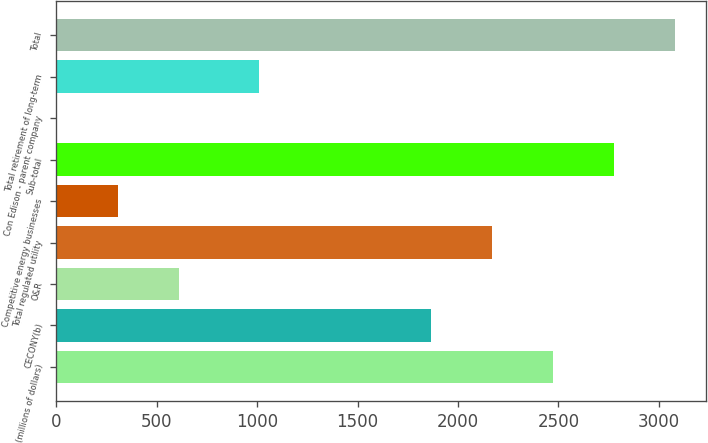Convert chart. <chart><loc_0><loc_0><loc_500><loc_500><bar_chart><fcel>(millions of dollars)<fcel>CECONY(b)<fcel>O&R<fcel>Total regulated utility<fcel>Competitive energy businesses<fcel>Sub-total<fcel>Con Edison - parent company<fcel>Total retirement of long-term<fcel>Total<nl><fcel>2473.4<fcel>1866<fcel>610.4<fcel>2169.7<fcel>306.7<fcel>2777.1<fcel>3<fcel>1011<fcel>3080.8<nl></chart> 